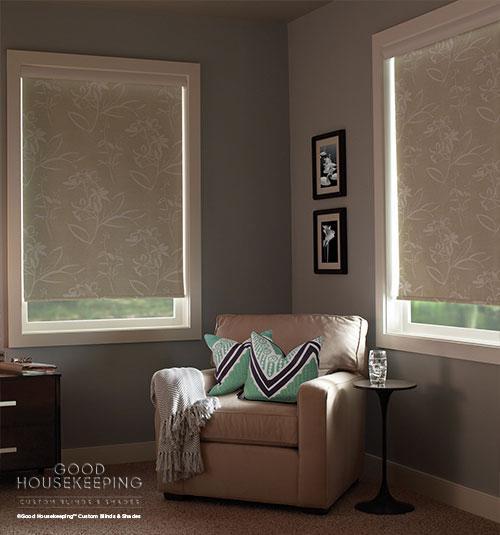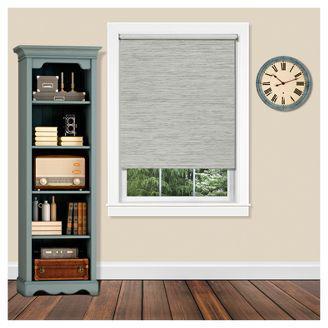The first image is the image on the left, the second image is the image on the right. Examine the images to the left and right. Is the description "The left and right image contains a total of five blinds." accurate? Answer yes or no. No. 